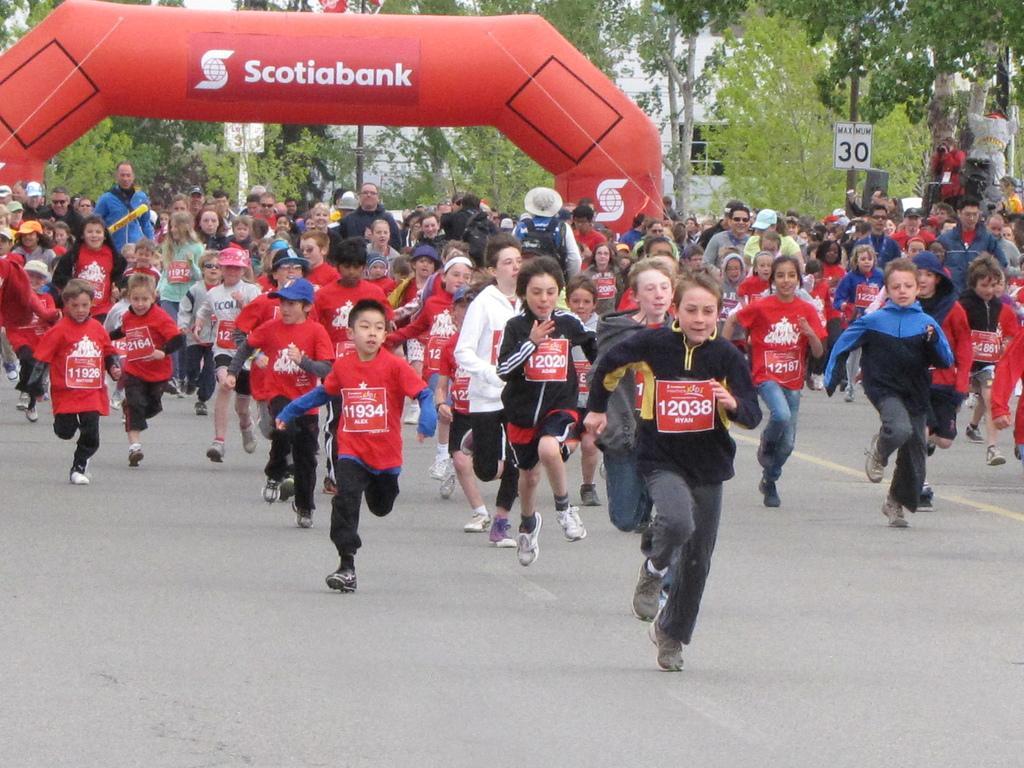Could you give a brief overview of what you see in this image? In this image we can see a group of children standing on the ground. One boy is wearing a cap. In the background, we can see a group of people standing, a sign board with some text, a group of trees, building with windows and a balloon arch. 